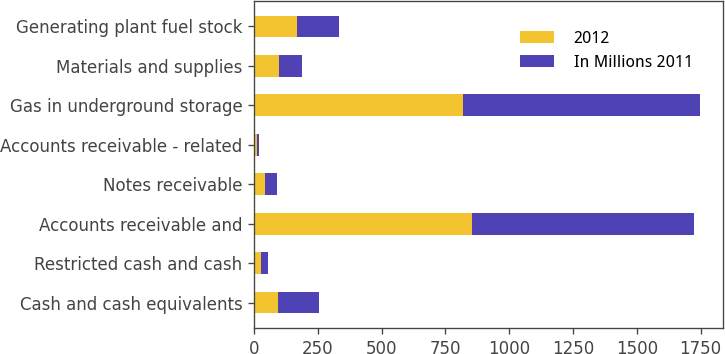<chart> <loc_0><loc_0><loc_500><loc_500><stacked_bar_chart><ecel><fcel>Cash and cash equivalents<fcel>Restricted cash and cash<fcel>Accounts receivable and<fcel>Notes receivable<fcel>Accounts receivable - related<fcel>Gas in underground storage<fcel>Materials and supplies<fcel>Generating plant fuel stock<nl><fcel>2012<fcel>93<fcel>29<fcel>855<fcel>41<fcel>10<fcel>820<fcel>96<fcel>168<nl><fcel>In Millions 2011<fcel>161<fcel>27<fcel>869<fcel>49<fcel>10<fcel>929<fcel>92<fcel>166<nl></chart> 